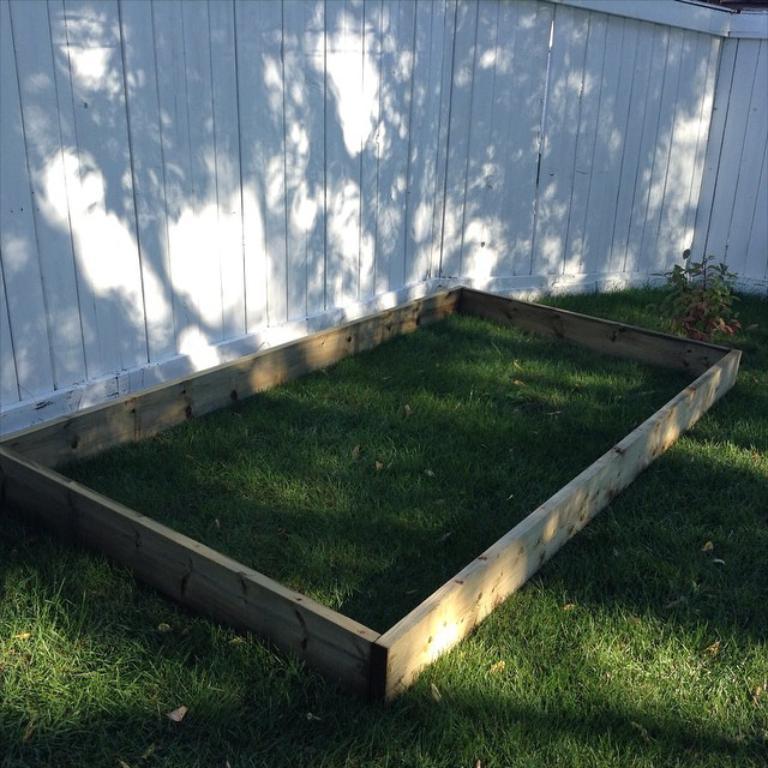In one or two sentences, can you explain what this image depicts? In this image I can see the wooden material on the grass. To the side there is a plant. In the back I can see the white color wooden wall. 